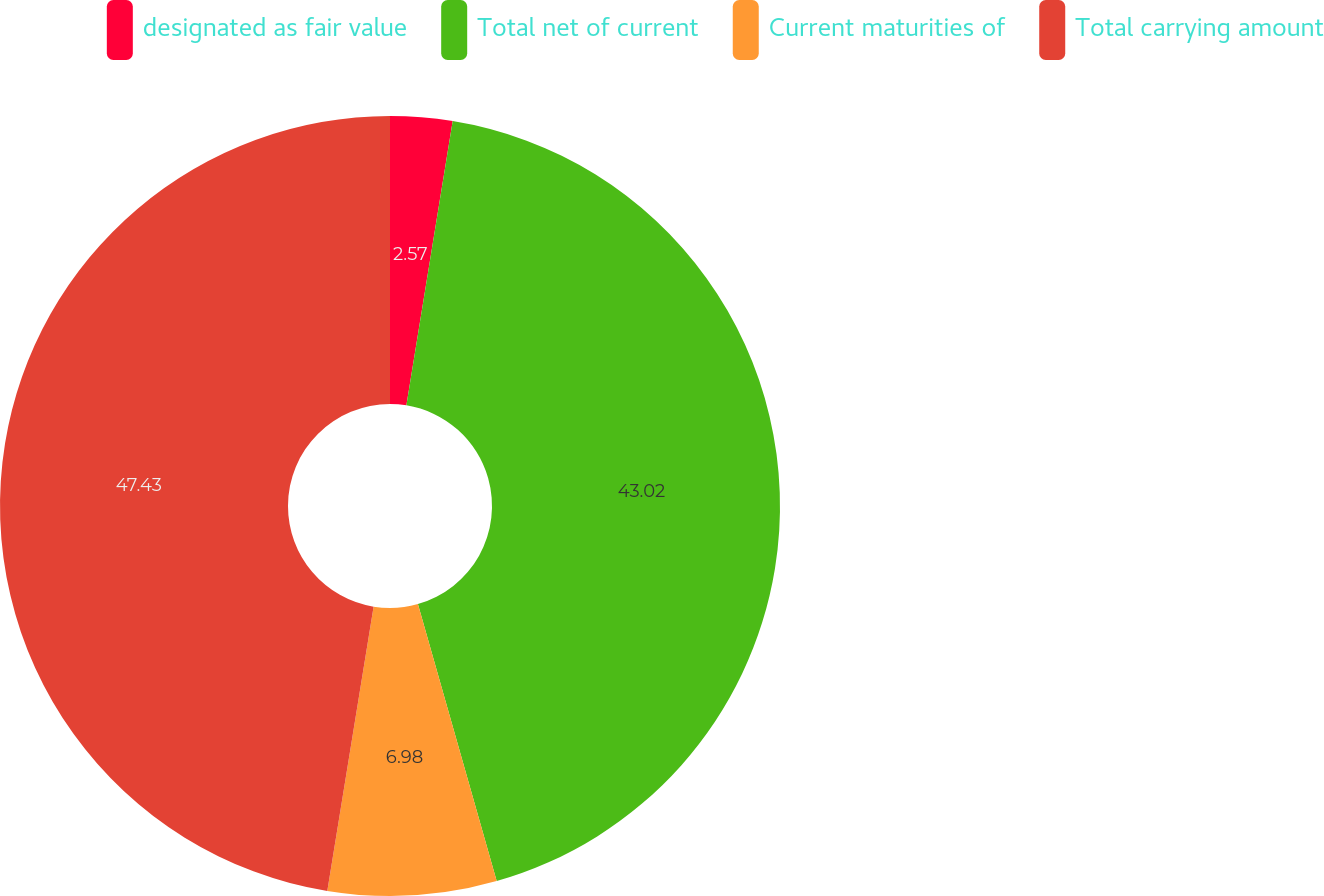<chart> <loc_0><loc_0><loc_500><loc_500><pie_chart><fcel>designated as fair value<fcel>Total net of current<fcel>Current maturities of<fcel>Total carrying amount<nl><fcel>2.57%<fcel>43.02%<fcel>6.98%<fcel>47.43%<nl></chart> 